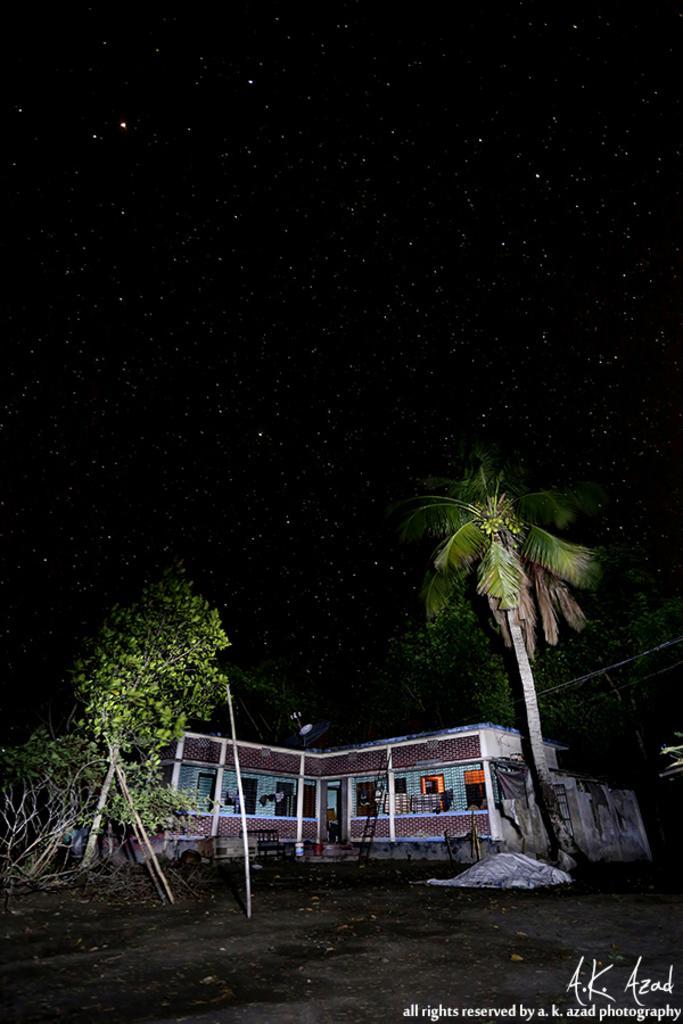Please provide a concise description of this image. At the bottom of the image there are some trees. Behind the trees there is building. 